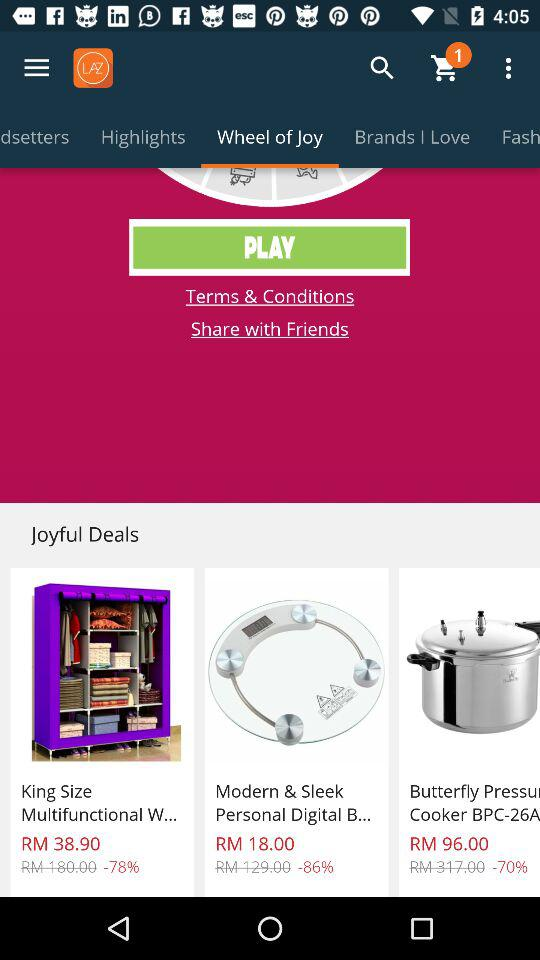How many items are on sale?
Answer the question using a single word or phrase. 3 